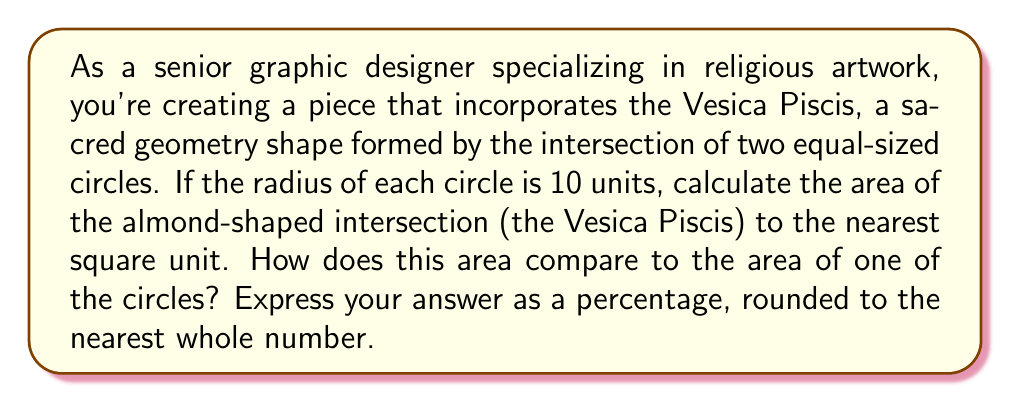Could you help me with this problem? Let's approach this step-by-step:

1) First, we need to calculate the area of the Vesica Piscis. The formula for this area is:

   $$A_{VP} = 4r^2(\frac{\pi}{6} - \frac{\sqrt{3}}{4})$$

   Where $r$ is the radius of the circles.

2) Substituting $r = 10$:

   $$A_{VP} = 4(10^2)(\frac{\pi}{6} - \frac{\sqrt{3}}{4})$$
   $$A_{VP} = 400(\frac{\pi}{6} - \frac{\sqrt{3}}{4})$$

3) Calculating this:

   $$A_{VP} \approx 66.37 \text{ square units}$$

4) Rounding to the nearest square unit:

   $$A_{VP} \approx 66 \text{ square units}$$

5) Now, let's calculate the area of one circle:

   $$A_C = \pi r^2 = \pi (10^2) = 100\pi \approx 314.16 \text{ square units}$$

6) To compare the areas, we calculate the percentage:

   $$\text{Percentage} = \frac{A_{VP}}{A_C} \times 100\% = \frac{66}{314.16} \times 100\% \approx 21\%$$

This calculation shows that the area of the Vesica Piscis is approximately 21% of the area of one complete circle.

[asy]
unitsize(10mm);
path c1 = circle((0,0),1);
path c2 = circle((1,0),1);
fill(c1 && c2, rgb(0.8,0.8,1));
draw(c1);
draw(c2);
label("r", (0.5,0.3));
[/asy]
Answer: The area of the Vesica Piscis is approximately 66 square units, which is about 21% of the area of one circle. 